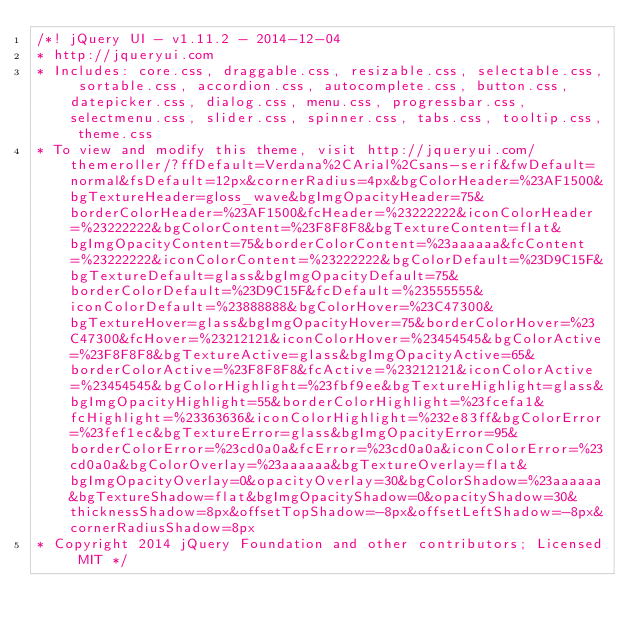<code> <loc_0><loc_0><loc_500><loc_500><_CSS_>/*! jQuery UI - v1.11.2 - 2014-12-04
* http://jqueryui.com
* Includes: core.css, draggable.css, resizable.css, selectable.css, sortable.css, accordion.css, autocomplete.css, button.css, datepicker.css, dialog.css, menu.css, progressbar.css, selectmenu.css, slider.css, spinner.css, tabs.css, tooltip.css, theme.css
* To view and modify this theme, visit http://jqueryui.com/themeroller/?ffDefault=Verdana%2CArial%2Csans-serif&fwDefault=normal&fsDefault=12px&cornerRadius=4px&bgColorHeader=%23AF1500&bgTextureHeader=gloss_wave&bgImgOpacityHeader=75&borderColorHeader=%23AF1500&fcHeader=%23222222&iconColorHeader=%23222222&bgColorContent=%23F8F8F8&bgTextureContent=flat&bgImgOpacityContent=75&borderColorContent=%23aaaaaa&fcContent=%23222222&iconColorContent=%23222222&bgColorDefault=%23D9C15F&bgTextureDefault=glass&bgImgOpacityDefault=75&borderColorDefault=%23D9C15F&fcDefault=%23555555&iconColorDefault=%23888888&bgColorHover=%23C47300&bgTextureHover=glass&bgImgOpacityHover=75&borderColorHover=%23C47300&fcHover=%23212121&iconColorHover=%23454545&bgColorActive=%23F8F8F8&bgTextureActive=glass&bgImgOpacityActive=65&borderColorActive=%23F8F8F8&fcActive=%23212121&iconColorActive=%23454545&bgColorHighlight=%23fbf9ee&bgTextureHighlight=glass&bgImgOpacityHighlight=55&borderColorHighlight=%23fcefa1&fcHighlight=%23363636&iconColorHighlight=%232e83ff&bgColorError=%23fef1ec&bgTextureError=glass&bgImgOpacityError=95&borderColorError=%23cd0a0a&fcError=%23cd0a0a&iconColorError=%23cd0a0a&bgColorOverlay=%23aaaaaa&bgTextureOverlay=flat&bgImgOpacityOverlay=0&opacityOverlay=30&bgColorShadow=%23aaaaaa&bgTextureShadow=flat&bgImgOpacityShadow=0&opacityShadow=30&thicknessShadow=8px&offsetTopShadow=-8px&offsetLeftShadow=-8px&cornerRadiusShadow=8px
* Copyright 2014 jQuery Foundation and other contributors; Licensed MIT */
</code> 